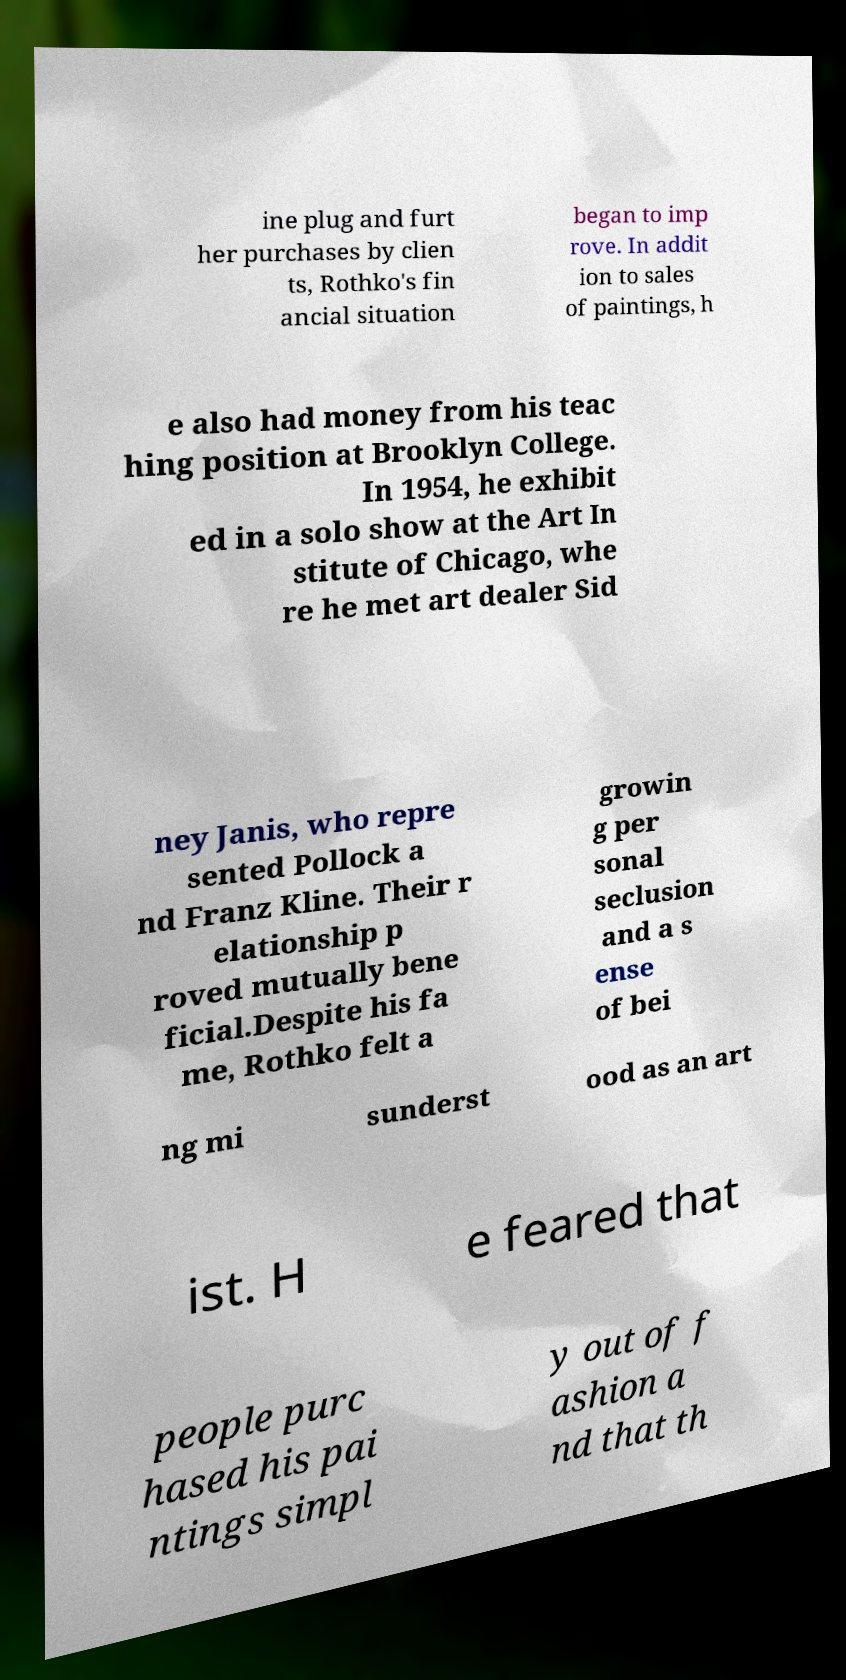Could you extract and type out the text from this image? ine plug and furt her purchases by clien ts, Rothko's fin ancial situation began to imp rove. In addit ion to sales of paintings, h e also had money from his teac hing position at Brooklyn College. In 1954, he exhibit ed in a solo show at the Art In stitute of Chicago, whe re he met art dealer Sid ney Janis, who repre sented Pollock a nd Franz Kline. Their r elationship p roved mutually bene ficial.Despite his fa me, Rothko felt a growin g per sonal seclusion and a s ense of bei ng mi sunderst ood as an art ist. H e feared that people purc hased his pai ntings simpl y out of f ashion a nd that th 